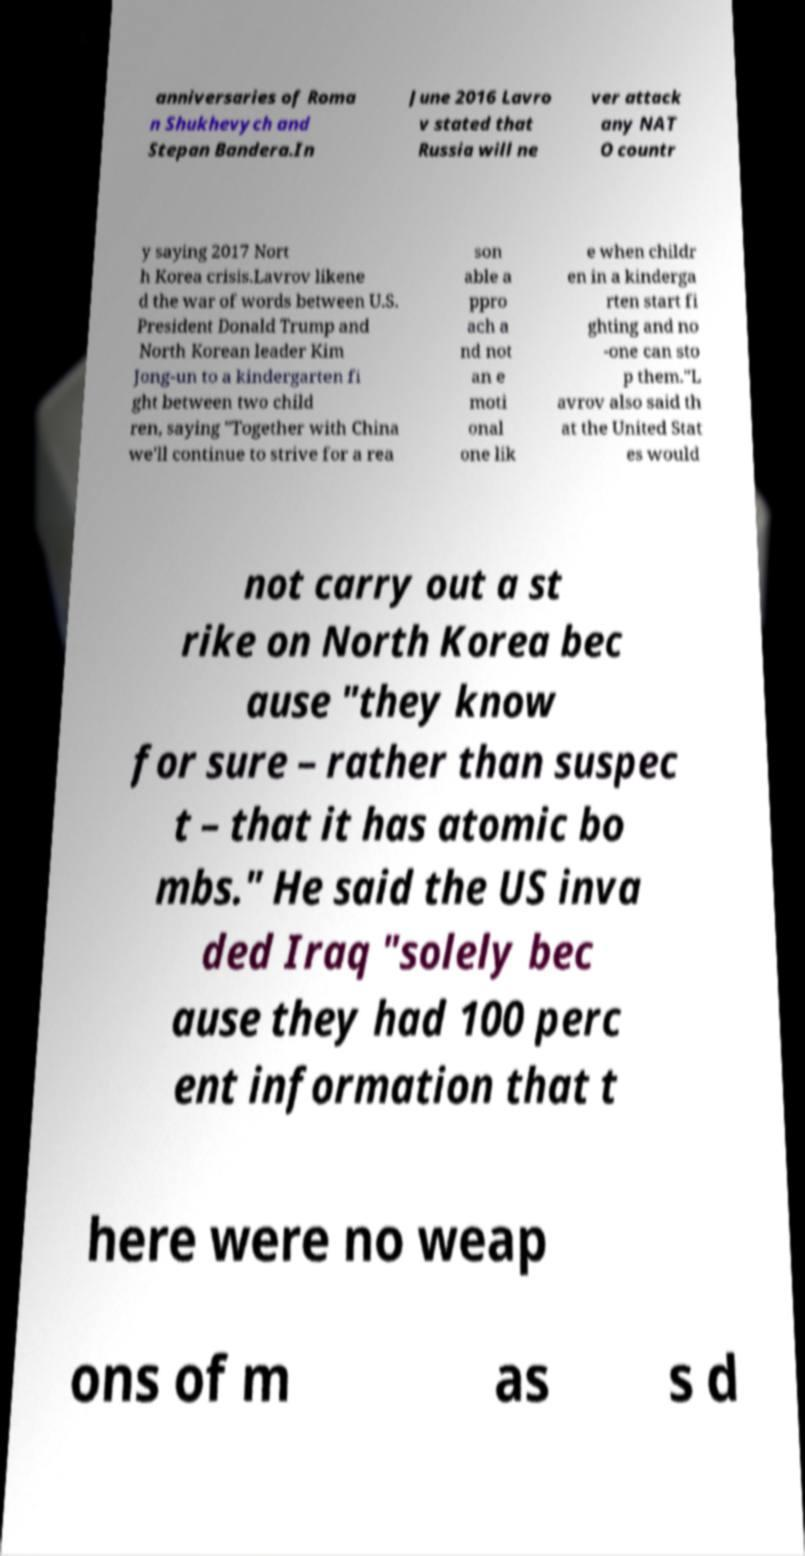Could you extract and type out the text from this image? anniversaries of Roma n Shukhevych and Stepan Bandera.In June 2016 Lavro v stated that Russia will ne ver attack any NAT O countr y saying 2017 Nort h Korea crisis.Lavrov likene d the war of words between U.S. President Donald Trump and North Korean leader Kim Jong-un to a kindergarten fi ght between two child ren, saying "Together with China we'll continue to strive for a rea son able a ppro ach a nd not an e moti onal one lik e when childr en in a kinderga rten start fi ghting and no -one can sto p them."L avrov also said th at the United Stat es would not carry out a st rike on North Korea bec ause "they know for sure – rather than suspec t – that it has atomic bo mbs." He said the US inva ded Iraq "solely bec ause they had 100 perc ent information that t here were no weap ons of m as s d 